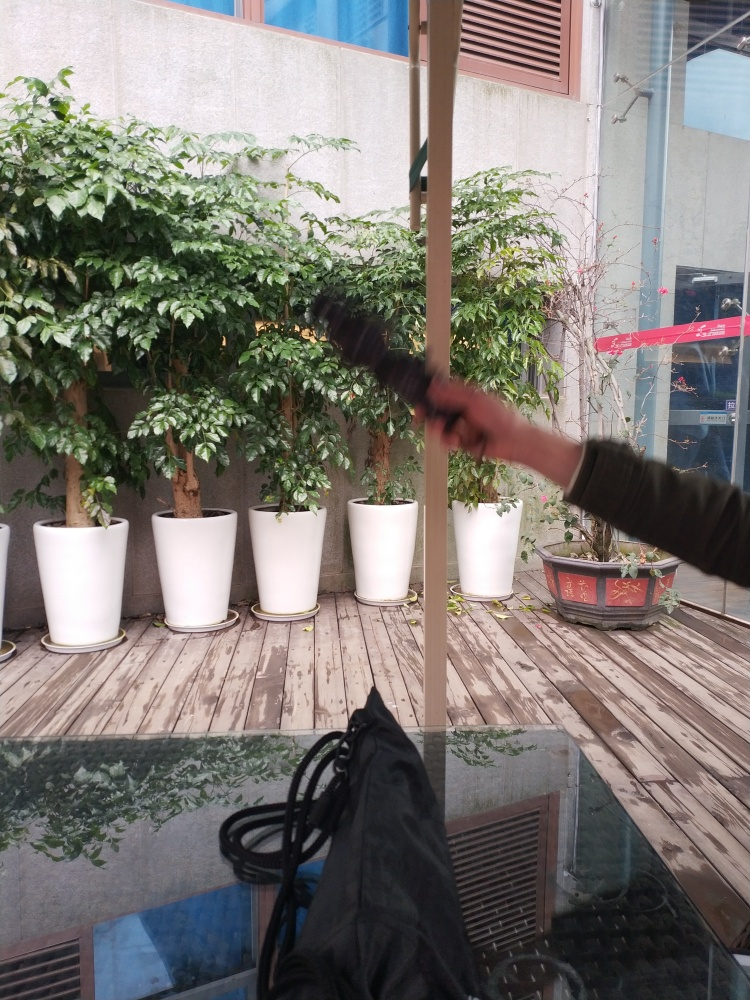Is this photo taken during the day or night? Based on the natural light visible through the window and the shadows cast by the plants, it appears that the photo is taken during the day. 